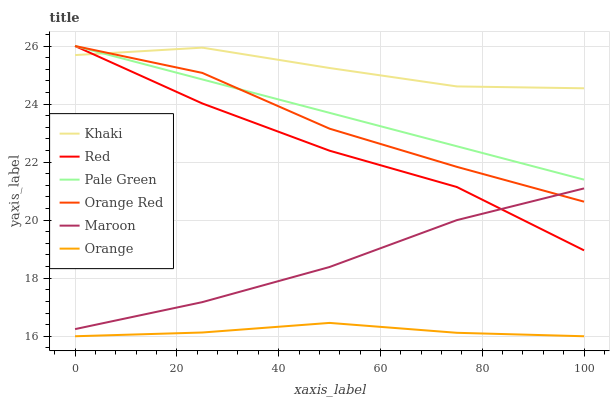Does Orange have the minimum area under the curve?
Answer yes or no. Yes. Does Khaki have the maximum area under the curve?
Answer yes or no. Yes. Does Maroon have the minimum area under the curve?
Answer yes or no. No. Does Maroon have the maximum area under the curve?
Answer yes or no. No. Is Pale Green the smoothest?
Answer yes or no. Yes. Is Orange Red the roughest?
Answer yes or no. Yes. Is Maroon the smoothest?
Answer yes or no. No. Is Maroon the roughest?
Answer yes or no. No. Does Maroon have the lowest value?
Answer yes or no. No. Does Red have the highest value?
Answer yes or no. Yes. Does Maroon have the highest value?
Answer yes or no. No. Is Orange less than Pale Green?
Answer yes or no. Yes. Is Orange Red greater than Orange?
Answer yes or no. Yes. Does Orange Red intersect Red?
Answer yes or no. Yes. Is Orange Red less than Red?
Answer yes or no. No. Is Orange Red greater than Red?
Answer yes or no. No. Does Orange intersect Pale Green?
Answer yes or no. No. 